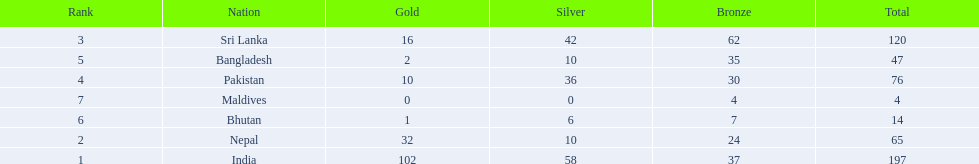What were the total amount won of medals by nations in the 1999 south asian games? 197, 65, 120, 76, 47, 14, 4. Which amount was the lowest? 4. Which nation had this amount? Maldives. 